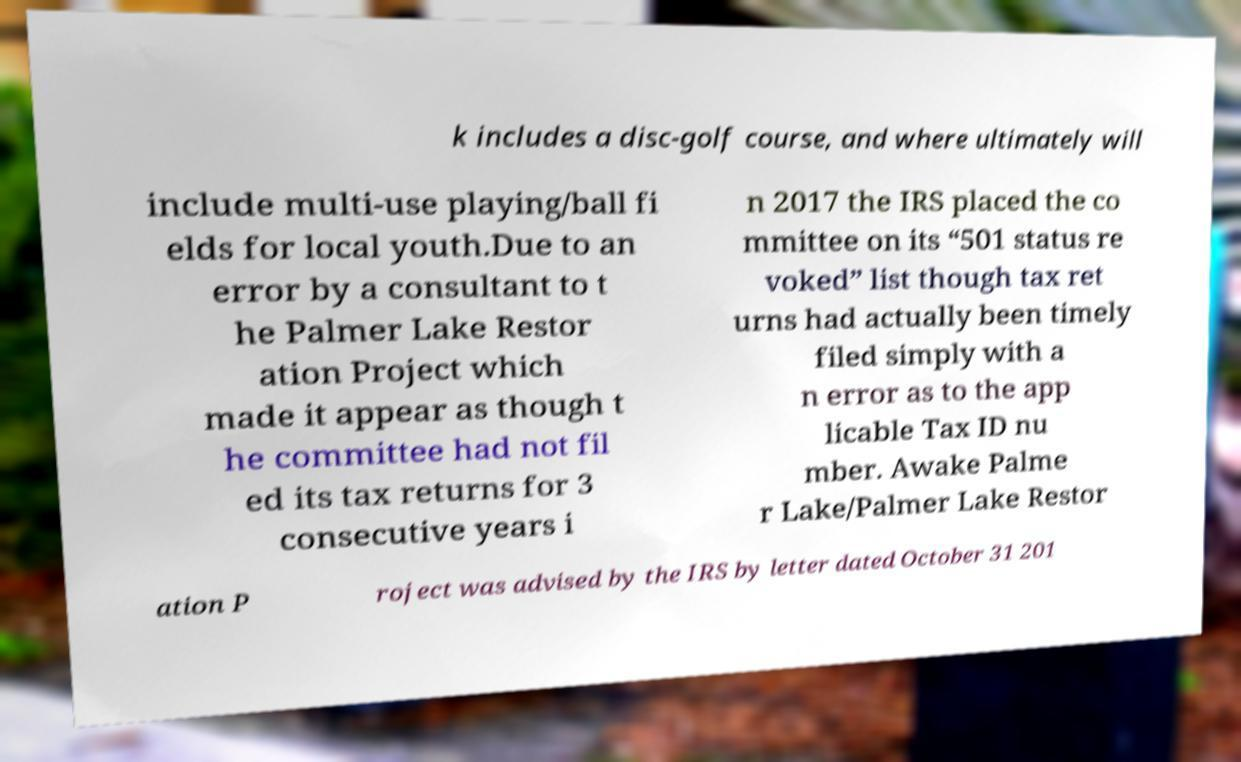There's text embedded in this image that I need extracted. Can you transcribe it verbatim? k includes a disc-golf course, and where ultimately will include multi-use playing/ball fi elds for local youth.Due to an error by a consultant to t he Palmer Lake Restor ation Project which made it appear as though t he committee had not fil ed its tax returns for 3 consecutive years i n 2017 the IRS placed the co mmittee on its “501 status re voked” list though tax ret urns had actually been timely filed simply with a n error as to the app licable Tax ID nu mber. Awake Palme r Lake/Palmer Lake Restor ation P roject was advised by the IRS by letter dated October 31 201 